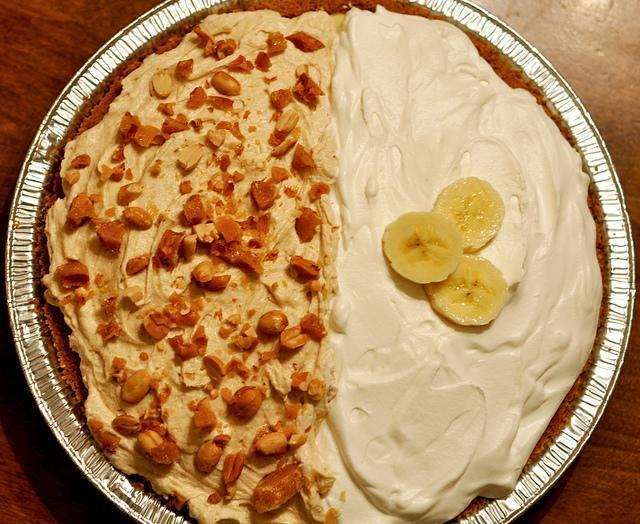How many bananas are on the pie?
Give a very brief answer. 3. How many people are there wearing black shirts?
Give a very brief answer. 0. 